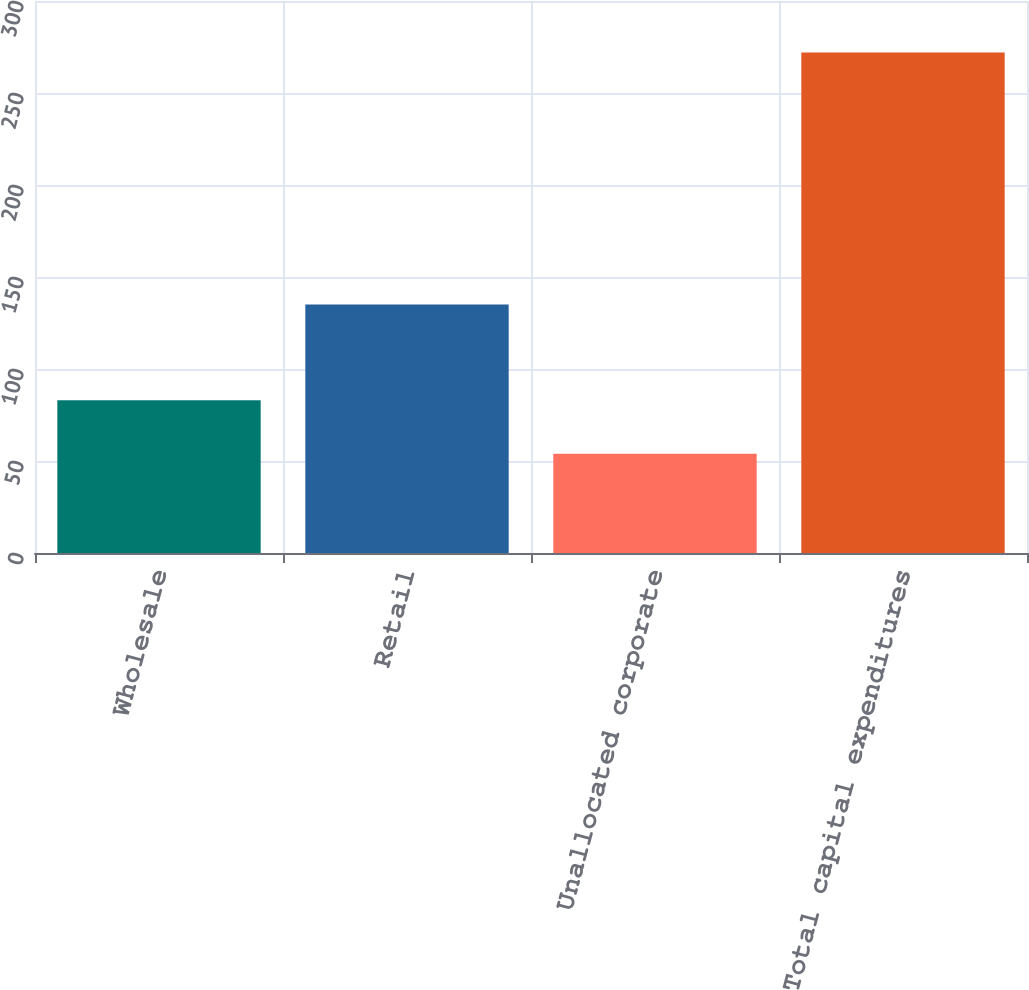<chart> <loc_0><loc_0><loc_500><loc_500><bar_chart><fcel>Wholesale<fcel>Retail<fcel>Unallocated corporate<fcel>Total capital expenditures<nl><fcel>83<fcel>135<fcel>54<fcel>272<nl></chart> 